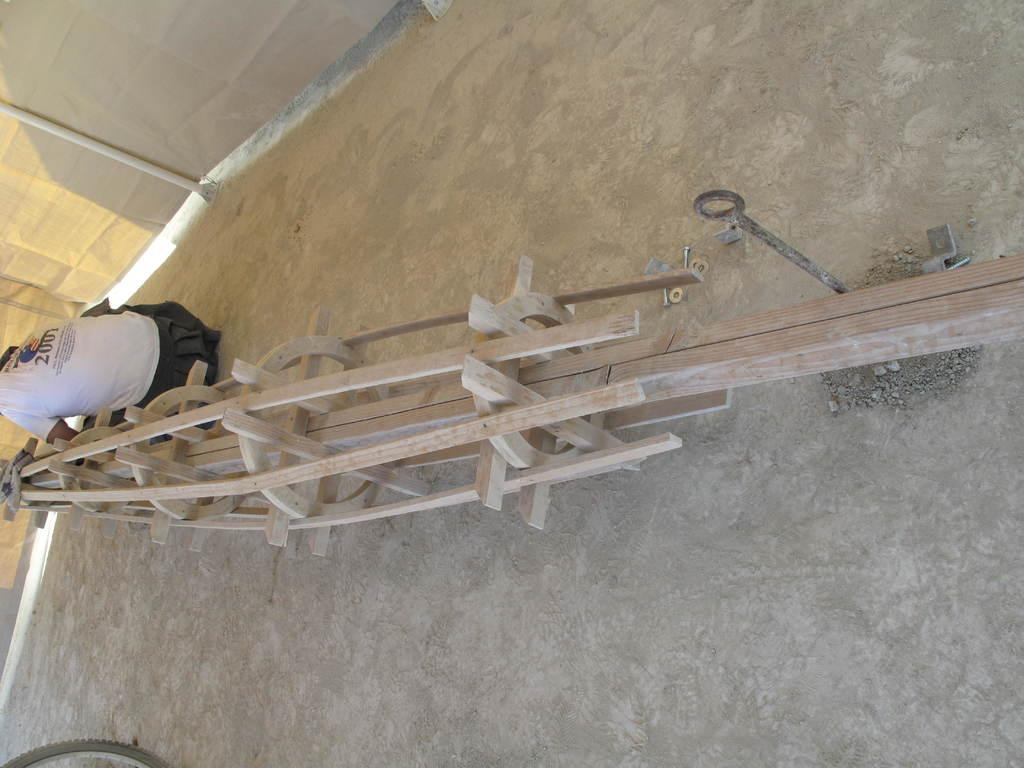What is the main object in the center of the image? There is a wooden object in the center of the image. Can you describe the person in the image? There is a person sitting on the ground beside the wooden object. What can be seen in the background of the image? There are curtains in the background of the image. What type of sand can be seen surrounding the wooden object in the image? There is no sand visible in the image; the wooden object is on a solid surface. 